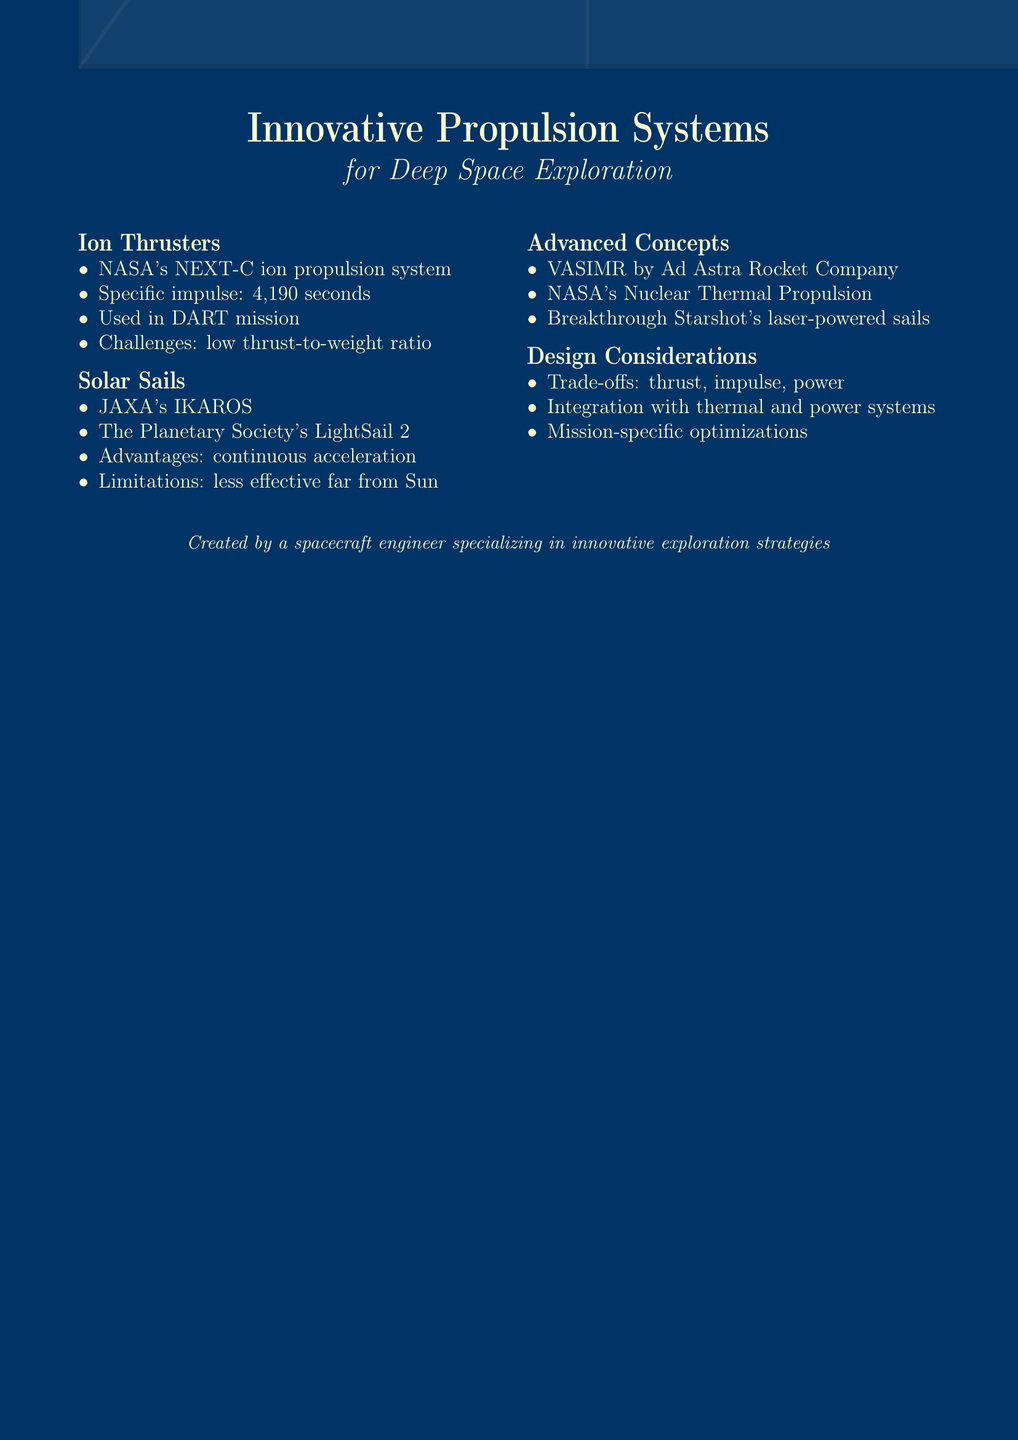what is the specific impulse of NASA's NEXT-C ion propulsion system? The specific impulse is provided in the document as 4,190 seconds, indicating its efficiency compared to chemical rockets.
Answer: 4,190 seconds which mission utilized ion propulsion systems? The document mentions that the DART mission applied ion propulsion systems in its operations.
Answer: DART what is a challenge associated with ion thrusters? The document lists that a challenge for ion thrusters is their low thrust-to-weight ratio, affecting their application in spacecraft design.
Answer: low thrust-to-weight ratio what is one advantage of solar sails? The document states that an advantage of solar sails is continuous acceleration, which allows for sustained propulsion without carrying propellant.
Answer: continuous acceleration which organization developed the IKAROS solar sail? The document specifies that the JAXA organization developed the IKAROS solar sail.
Answer: JAXA what trade-offs are mentioned in the design considerations? The design considerations discussed trade-offs between thrust, specific impulse, and power requirements for different propulsion systems.
Answer: thrust, specific impulse, and power what does VASIMR stand for? The document indicates that VASIMR refers to Variable Specific Impulse Magnetoplasma Rocket, highlighting its advanced propulsion concept.
Answer: Variable Specific Impulse Magnetoplasma Rocket what is a limitation of solar sails mentioned in the document? As stated in the document, a limitation of solar sails is their decreasing effectiveness with distance from the Sun, which impacts their operational range.
Answer: decreasing effectiveness with distance from the Sun which propulsion system is associated with Breakthrough Starshot? The document connects Breakthrough Starshot with laser-powered light sails, indicating its innovative approach to interstellar travel.
Answer: laser-powered light sails 